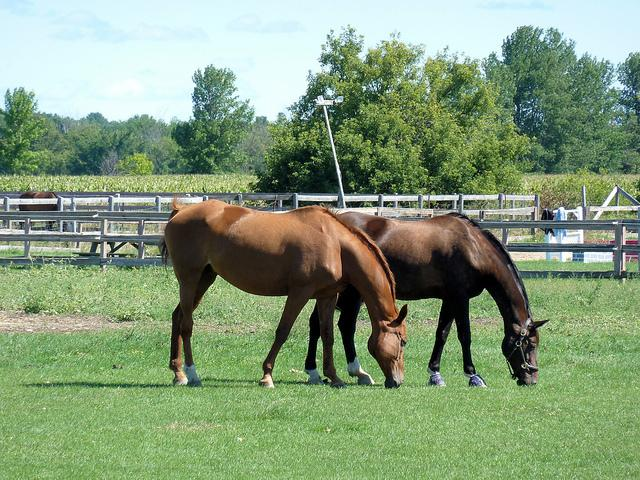Who likely owns these horses?

Choices:
A) circus
B) rancher
C) zookeeper
D) jockey rancher 